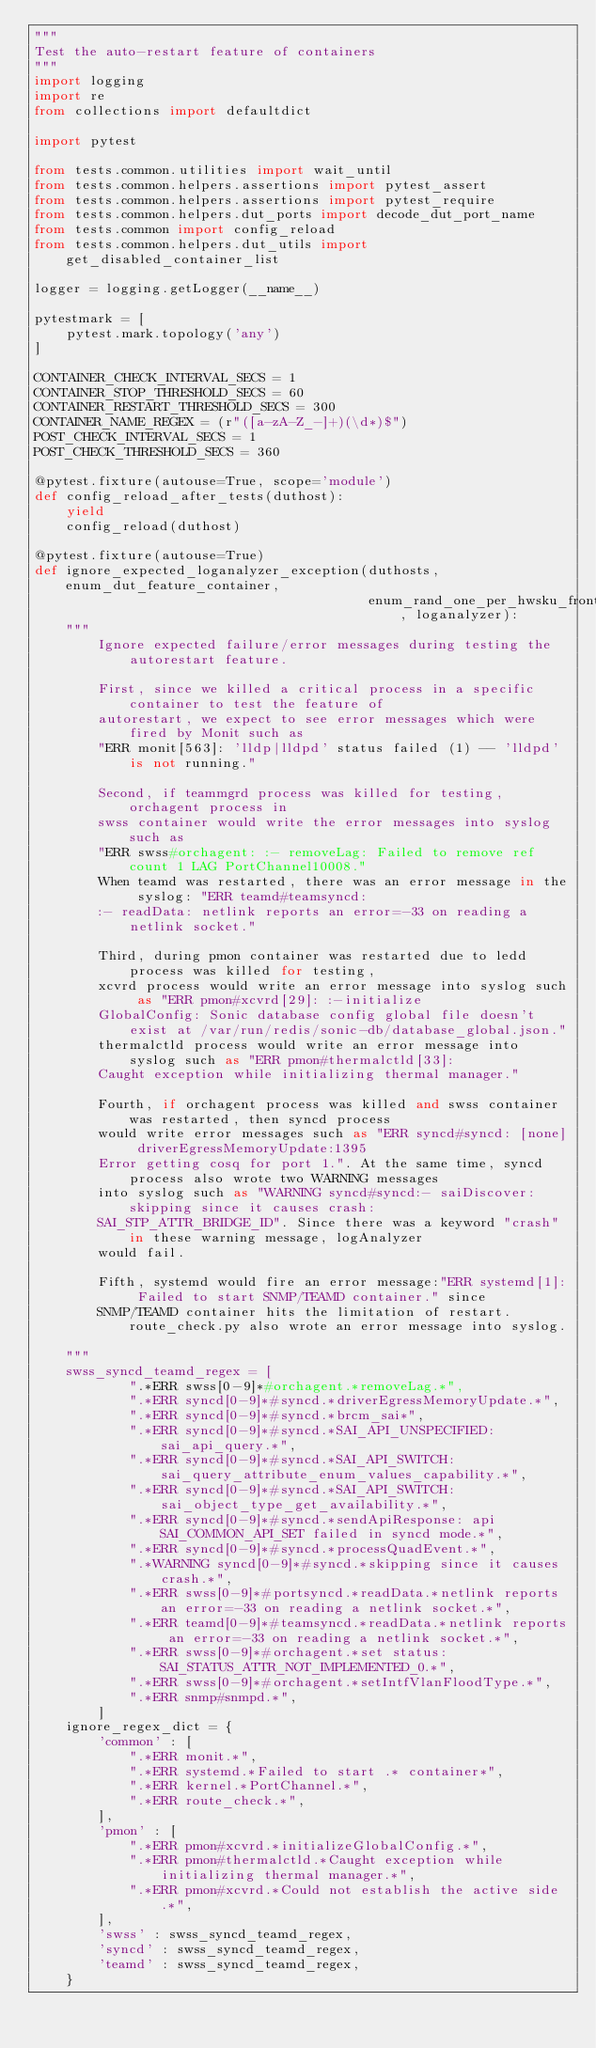Convert code to text. <code><loc_0><loc_0><loc_500><loc_500><_Python_>"""
Test the auto-restart feature of containers
"""
import logging
import re
from collections import defaultdict

import pytest

from tests.common.utilities import wait_until
from tests.common.helpers.assertions import pytest_assert
from tests.common.helpers.assertions import pytest_require
from tests.common.helpers.dut_ports import decode_dut_port_name
from tests.common import config_reload
from tests.common.helpers.dut_utils import get_disabled_container_list

logger = logging.getLogger(__name__)

pytestmark = [
    pytest.mark.topology('any')
]

CONTAINER_CHECK_INTERVAL_SECS = 1
CONTAINER_STOP_THRESHOLD_SECS = 60
CONTAINER_RESTART_THRESHOLD_SECS = 300
CONTAINER_NAME_REGEX = (r"([a-zA-Z_-]+)(\d*)$")
POST_CHECK_INTERVAL_SECS = 1
POST_CHECK_THRESHOLD_SECS = 360

@pytest.fixture(autouse=True, scope='module')
def config_reload_after_tests(duthost):
    yield
    config_reload(duthost)

@pytest.fixture(autouse=True)
def ignore_expected_loganalyzer_exception(duthosts, enum_dut_feature_container,
                                          enum_rand_one_per_hwsku_frontend_hostname, loganalyzer):
    """
        Ignore expected failure/error messages during testing the autorestart feature.

        First, since we killed a critical process in a specific container to test the feature of
        autorestart, we expect to see error messages which were fired by Monit such as
        "ERR monit[563]: 'lldp|lldpd' status failed (1) -- 'lldpd' is not running."

        Second, if teammgrd process was killed for testing, orchagent process in
        swss container would write the error messages into syslog such as
        "ERR swss#orchagent: :- removeLag: Failed to remove ref count 1 LAG PortChannel10008."
        When teamd was restarted, there was an error message in the syslog: "ERR teamd#teamsyncd:
        :- readData: netlink reports an error=-33 on reading a netlink socket."

        Third, during pmon container was restarted due to ledd process was killed for testing,
        xcvrd process would write an error message into syslog such as "ERR pmon#xcvrd[29]: :-initialize
        GlobalConfig: Sonic database config global file doesn't exist at /var/run/redis/sonic-db/database_global.json."
        thermalctld process would write an error message into syslog such as "ERR pmon#thermalctld[33]:
        Caught exception while initializing thermal manager."

        Fourth, if orchagent process was killed and swss container was restarted, then syncd process
        would write error messages such as "ERR syncd#syncd: [none] driverEgressMemoryUpdate:1395
        Error getting cosq for port 1.". At the same time, syncd process also wrote two WARNING messages
        into syslog such as "WARNING syncd#syncd:- saiDiscover: skipping since it causes crash:
        SAI_STP_ATTR_BRIDGE_ID". Since there was a keyword "crash" in these warning message, logAnalyzer
        would fail.

        Fifth, systemd would fire an error message:"ERR systemd[1]: Failed to start SNMP/TEAMD container." since
        SNMP/TEAMD container hits the limitation of restart. route_check.py also wrote an error message into syslog.

    """
    swss_syncd_teamd_regex = [
            ".*ERR swss[0-9]*#orchagent.*removeLag.*",
            ".*ERR syncd[0-9]*#syncd.*driverEgressMemoryUpdate.*",
            ".*ERR syncd[0-9]*#syncd.*brcm_sai*",
            ".*ERR syncd[0-9]*#syncd.*SAI_API_UNSPECIFIED:sai_api_query.*",
            ".*ERR syncd[0-9]*#syncd.*SAI_API_SWITCH:sai_query_attribute_enum_values_capability.*",
            ".*ERR syncd[0-9]*#syncd.*SAI_API_SWITCH:sai_object_type_get_availability.*",
            ".*ERR syncd[0-9]*#syncd.*sendApiResponse: api SAI_COMMON_API_SET failed in syncd mode.*",
            ".*ERR syncd[0-9]*#syncd.*processQuadEvent.*",
            ".*WARNING syncd[0-9]*#syncd.*skipping since it causes crash.*",
            ".*ERR swss[0-9]*#portsyncd.*readData.*netlink reports an error=-33 on reading a netlink socket.*",
            ".*ERR teamd[0-9]*#teamsyncd.*readData.*netlink reports an error=-33 on reading a netlink socket.*",
            ".*ERR swss[0-9]*#orchagent.*set status: SAI_STATUS_ATTR_NOT_IMPLEMENTED_0.*",
            ".*ERR swss[0-9]*#orchagent.*setIntfVlanFloodType.*",
            ".*ERR snmp#snmpd.*",
        ]
    ignore_regex_dict = {
        'common' : [
            ".*ERR monit.*",
            ".*ERR systemd.*Failed to start .* container*",
            ".*ERR kernel.*PortChannel.*",
            ".*ERR route_check.*",
        ],
        'pmon' : [
            ".*ERR pmon#xcvrd.*initializeGlobalConfig.*",
            ".*ERR pmon#thermalctld.*Caught exception while initializing thermal manager.*",
            ".*ERR pmon#xcvrd.*Could not establish the active side.*",
        ],
        'swss' : swss_syncd_teamd_regex,
        'syncd' : swss_syncd_teamd_regex,
        'teamd' : swss_syncd_teamd_regex,
    }
</code> 